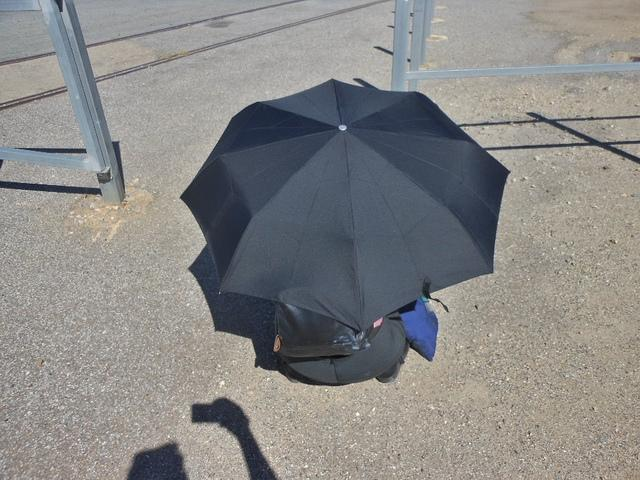Why does the photographer cast a shadow? Please explain your reasoning. blocks light. The person taking the photo is blocking the sun and that is what casts the shadow. 